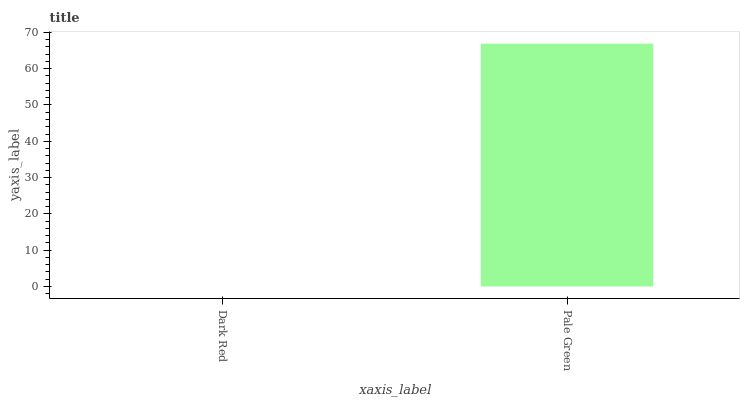Is Dark Red the minimum?
Answer yes or no. Yes. Is Pale Green the maximum?
Answer yes or no. Yes. Is Pale Green the minimum?
Answer yes or no. No. Is Pale Green greater than Dark Red?
Answer yes or no. Yes. Is Dark Red less than Pale Green?
Answer yes or no. Yes. Is Dark Red greater than Pale Green?
Answer yes or no. No. Is Pale Green less than Dark Red?
Answer yes or no. No. Is Pale Green the high median?
Answer yes or no. Yes. Is Dark Red the low median?
Answer yes or no. Yes. Is Dark Red the high median?
Answer yes or no. No. Is Pale Green the low median?
Answer yes or no. No. 